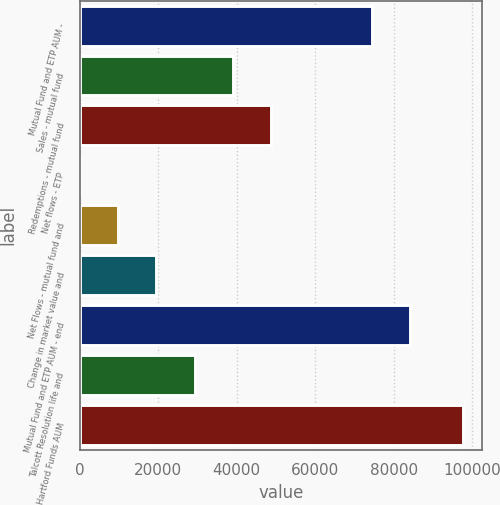Convert chart to OTSL. <chart><loc_0><loc_0><loc_500><loc_500><bar_chart><fcel>Mutual Fund and ETP AUM -<fcel>Sales - mutual fund<fcel>Redemptions - mutual fund<fcel>Net flows - ETP<fcel>Net Flows - mutual fund and<fcel>Change in market value and<fcel>Mutual Fund and ETP AUM - end<fcel>Talcott Resolution life and<fcel>Hartford Funds AUM<nl><fcel>74413<fcel>39011.6<fcel>48762.5<fcel>8<fcel>9758.9<fcel>19509.8<fcel>84163.9<fcel>29260.7<fcel>97517<nl></chart> 